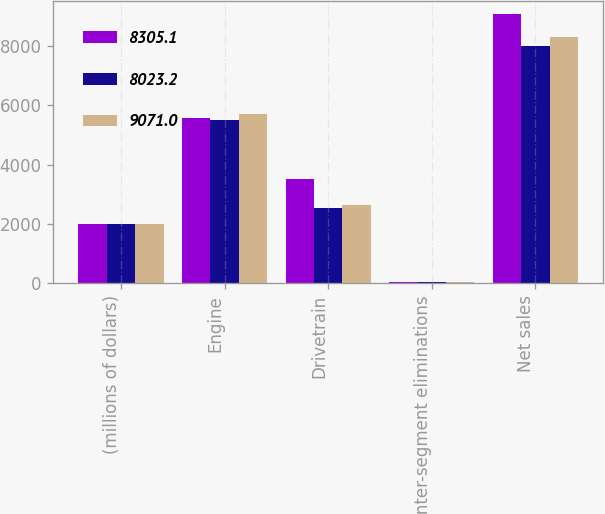Convert chart to OTSL. <chart><loc_0><loc_0><loc_500><loc_500><stacked_bar_chart><ecel><fcel>(millions of dollars)<fcel>Engine<fcel>Drivetrain<fcel>Inter-segment eliminations<fcel>Net sales<nl><fcel>8305.1<fcel>2016<fcel>5590.1<fcel>3523.7<fcel>42.8<fcel>9071<nl><fcel>8023.2<fcel>2015<fcel>5500<fcel>2556.7<fcel>33.5<fcel>8023.2<nl><fcel>9071<fcel>2014<fcel>5705.9<fcel>2631.4<fcel>32.2<fcel>8305.1<nl></chart> 